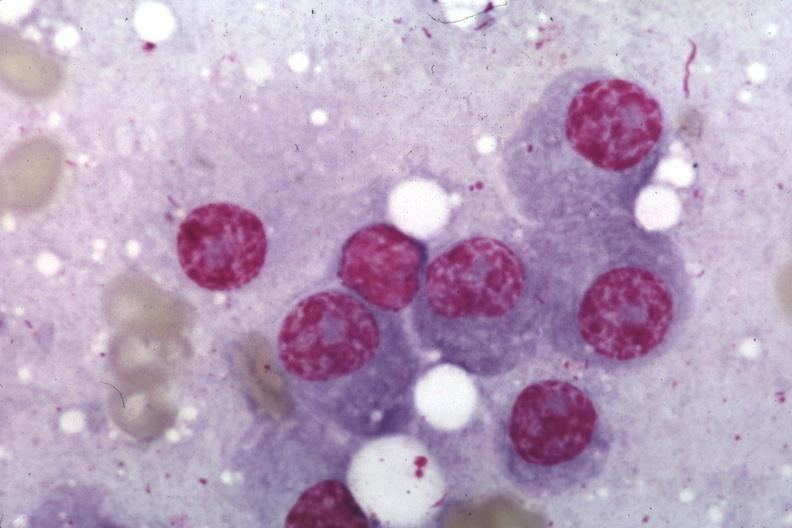s hematologic present?
Answer the question using a single word or phrase. Yes 